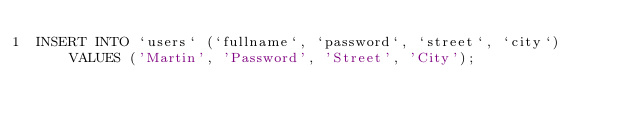<code> <loc_0><loc_0><loc_500><loc_500><_SQL_>INSERT INTO `users` (`fullname`, `password`, `street`, `city`) VALUES ('Martin', 'Password', 'Street', 'City');</code> 